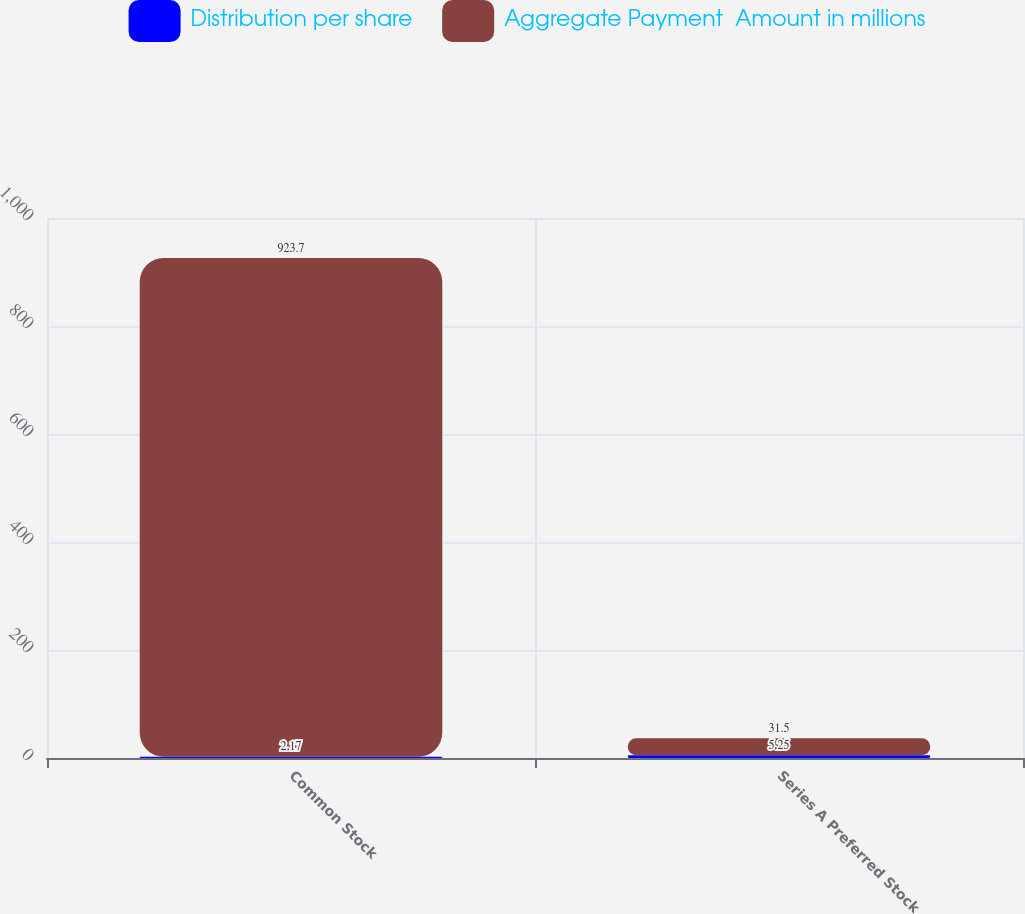<chart> <loc_0><loc_0><loc_500><loc_500><stacked_bar_chart><ecel><fcel>Common Stock<fcel>Series A Preferred Stock<nl><fcel>Distribution per share<fcel>2.17<fcel>5.25<nl><fcel>Aggregate Payment  Amount in millions<fcel>923.7<fcel>31.5<nl></chart> 